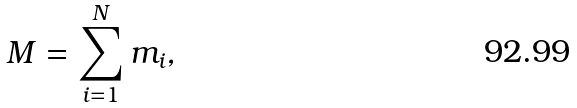Convert formula to latex. <formula><loc_0><loc_0><loc_500><loc_500>M = \sum _ { i = 1 } ^ { N } { m _ { i } } ,</formula> 